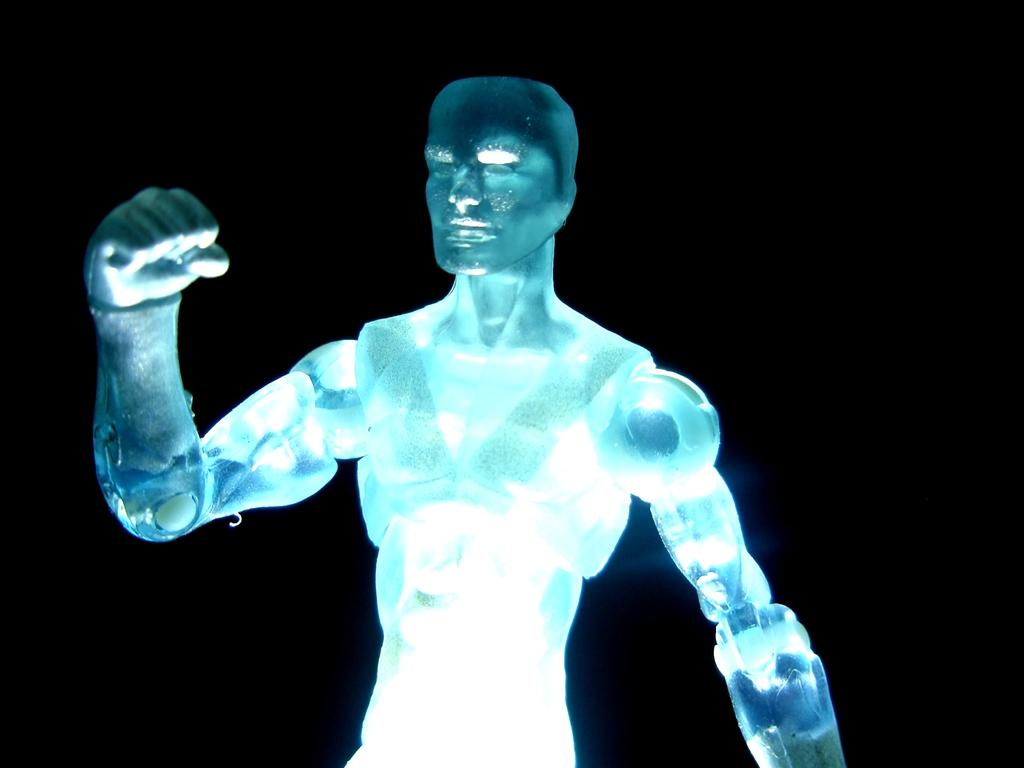What is the main subject of the image? There is a depiction of a person in the image. What color is the background of the image? The background of the image is black. How many boats are visible in the image? There are no boats present in the image. What type of animal can be seen interacting with the person in the image? There is no animal present in the image; it only depicts a person. 